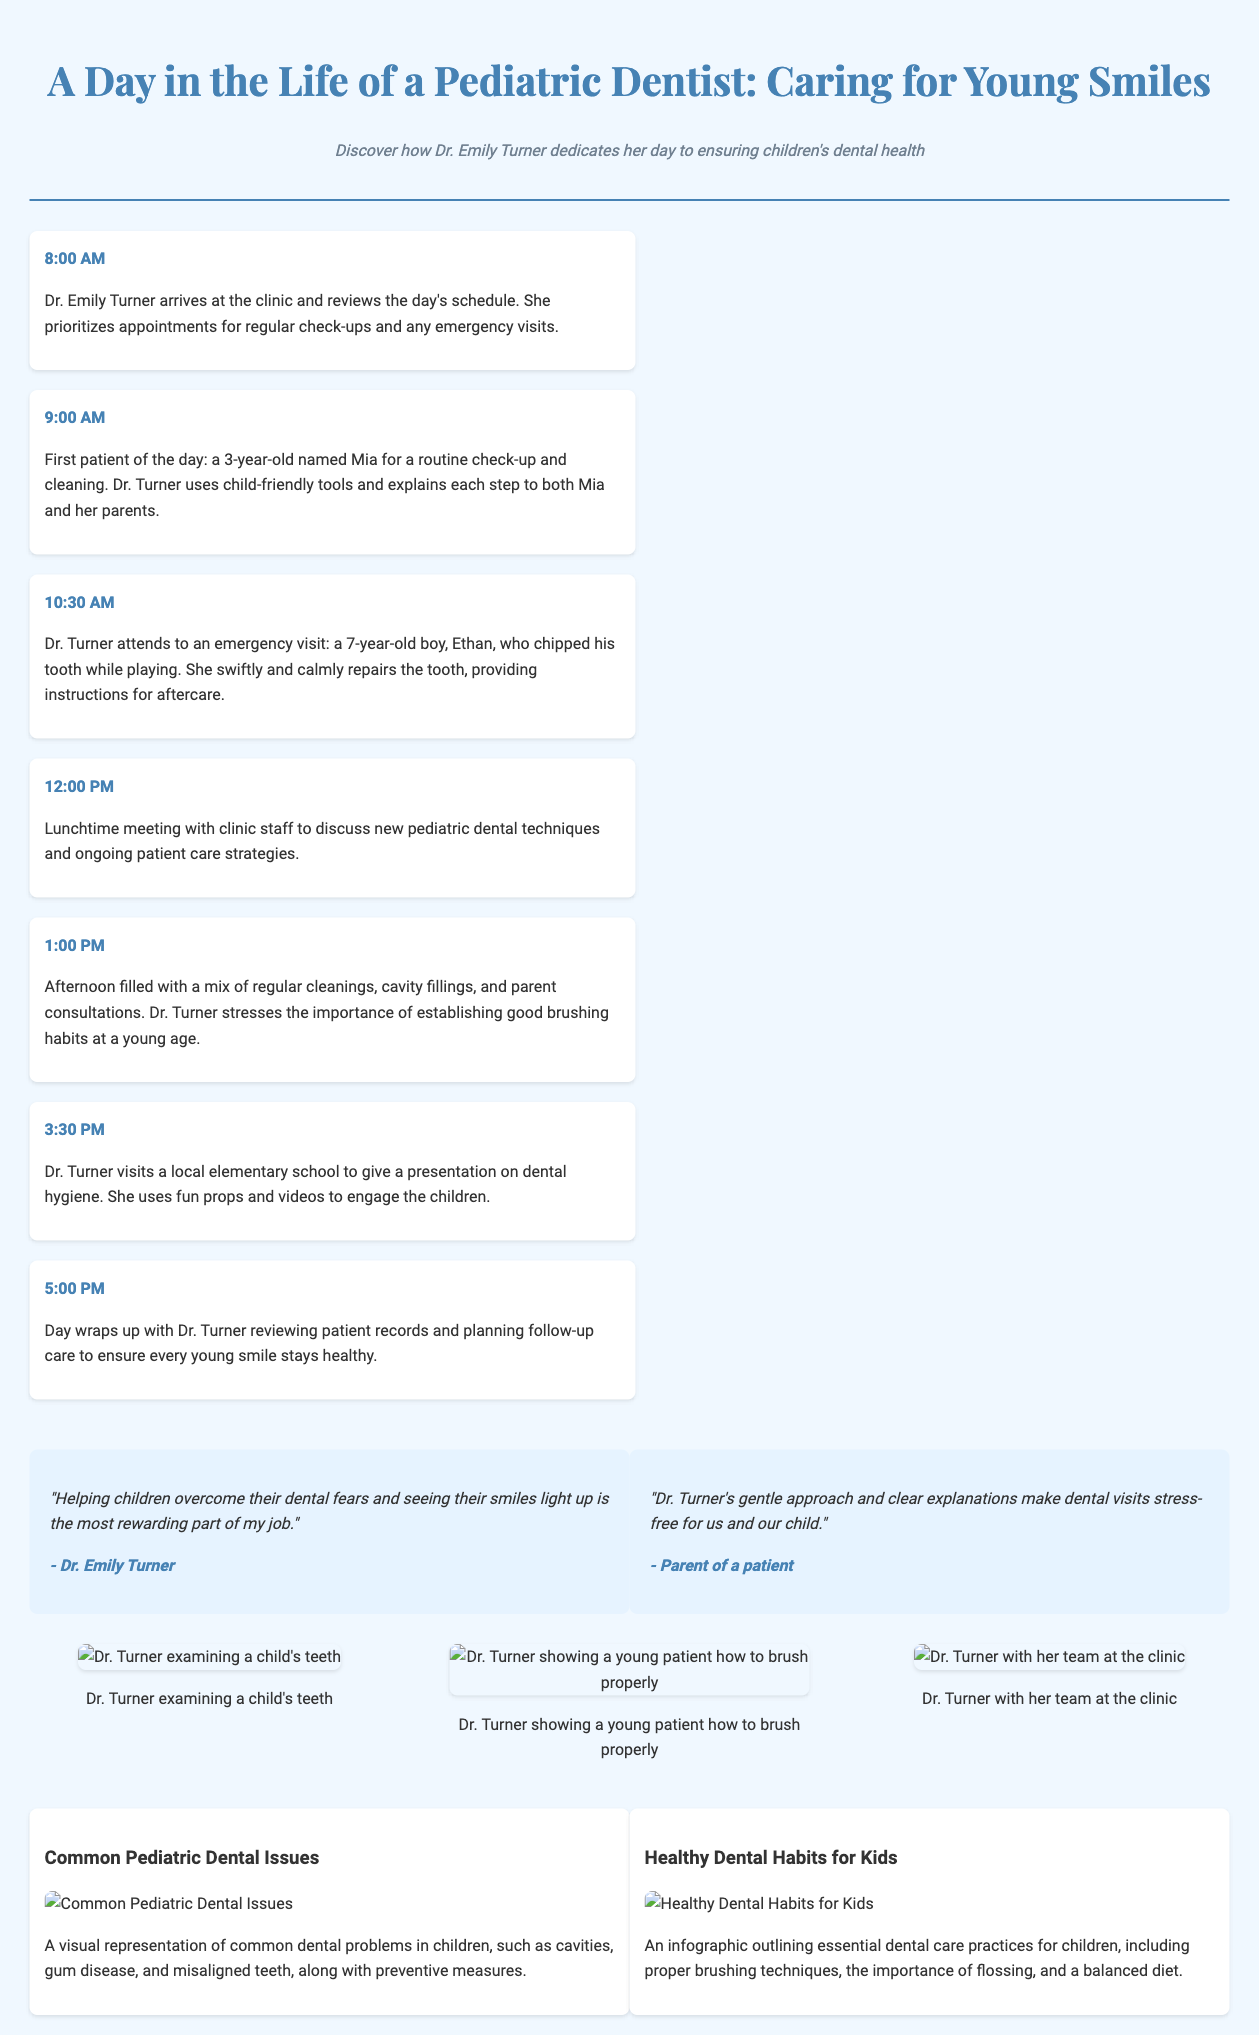what time does Dr. Turner start her day? Dr. Turner begins her day at 8:00 AM according to the timeline in the document.
Answer: 8:00 AM who is the first patient of the day? The first patient mentioned in the timeline is Mia, a 3-year-old girl.
Answer: Mia what type of problems does Dr. Turner address during the emergency visit? The emergency visit involves a 7-year-old boy, Ethan, who chipped his tooth.
Answer: chipped tooth what is a key theme present in Dr. Turner's quotes? Dr. Turner's quotes emphasize the importance of helping children overcome dental fears and ensuring stress-free visits.
Answer: overcoming dental fears what did Dr. Turner engage children with during her school presentation? Dr. Turner used fun props and videos to engage the children during her presentation on dental hygiene.
Answer: fun props and videos how many photos are included in the layout? There are three photos showing Dr. Turner interacting with her patients and team in the layout.
Answer: three what are the two main infographics titled? The titles of the infographics are "Common Pediatric Dental Issues" and "Healthy Dental Habits for Kids."
Answer: Common Pediatric Dental Issues, Healthy Dental Habits for Kids how does the document visually represent dental issues? The document visually represents dental issues using an infographic highlighting common problems such as cavities and gum disease.
Answer: infographic what time does Dr. Turner wrap up her day? According to the timeline, Dr. Turner wraps up her day at 5:00 PM.
Answer: 5:00 PM 